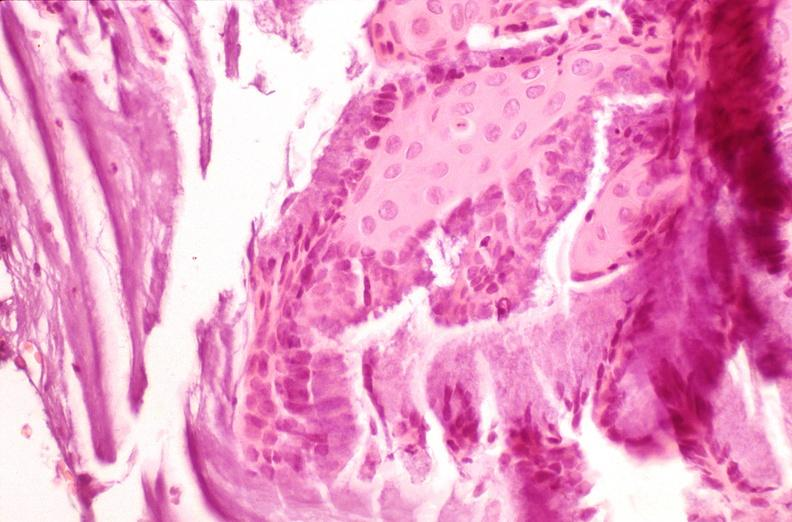does leiomyosarcoma show cervix, squamous metaplasia?
Answer the question using a single word or phrase. No 